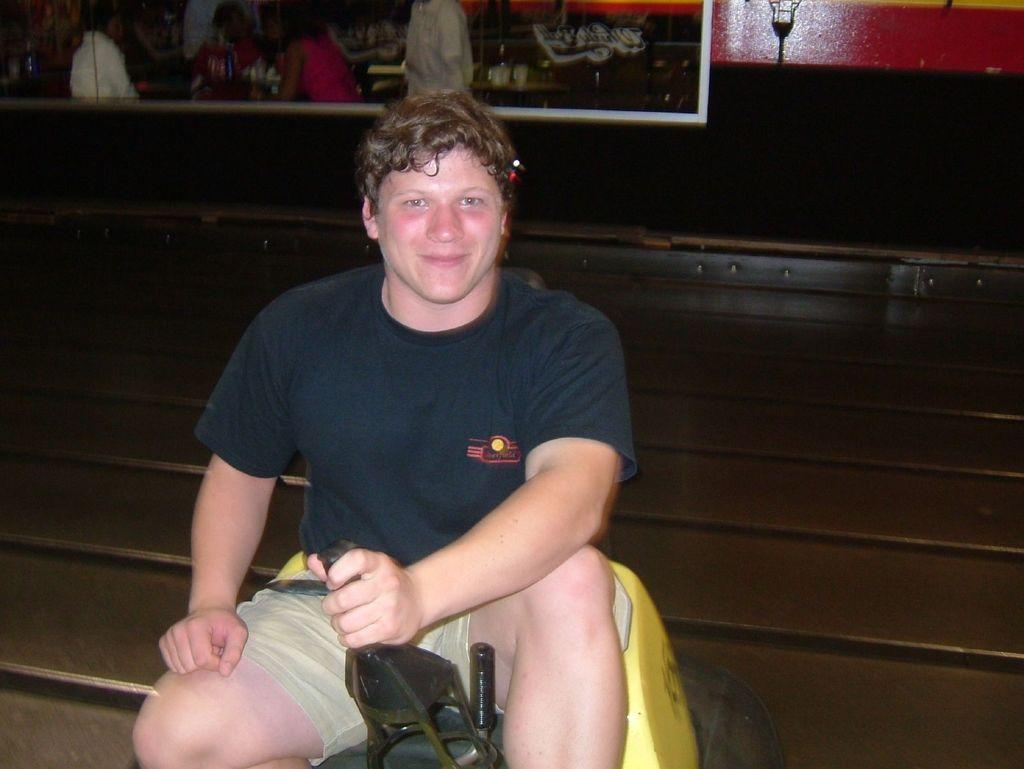What is the man in the image doing? The man is sitting on a bench in the image. What is the man holding in the image? The man is holding an object in the image. What can be seen in the background of the image? There is a board, a wall, and a light in the background of the image. What type of dust can be seen covering the industry in the image? There is no dust or industry present in the image. How does the earthquake affect the man sitting on the bench in the image? There is no earthquake depicted in the image, so its effects cannot be determined. 